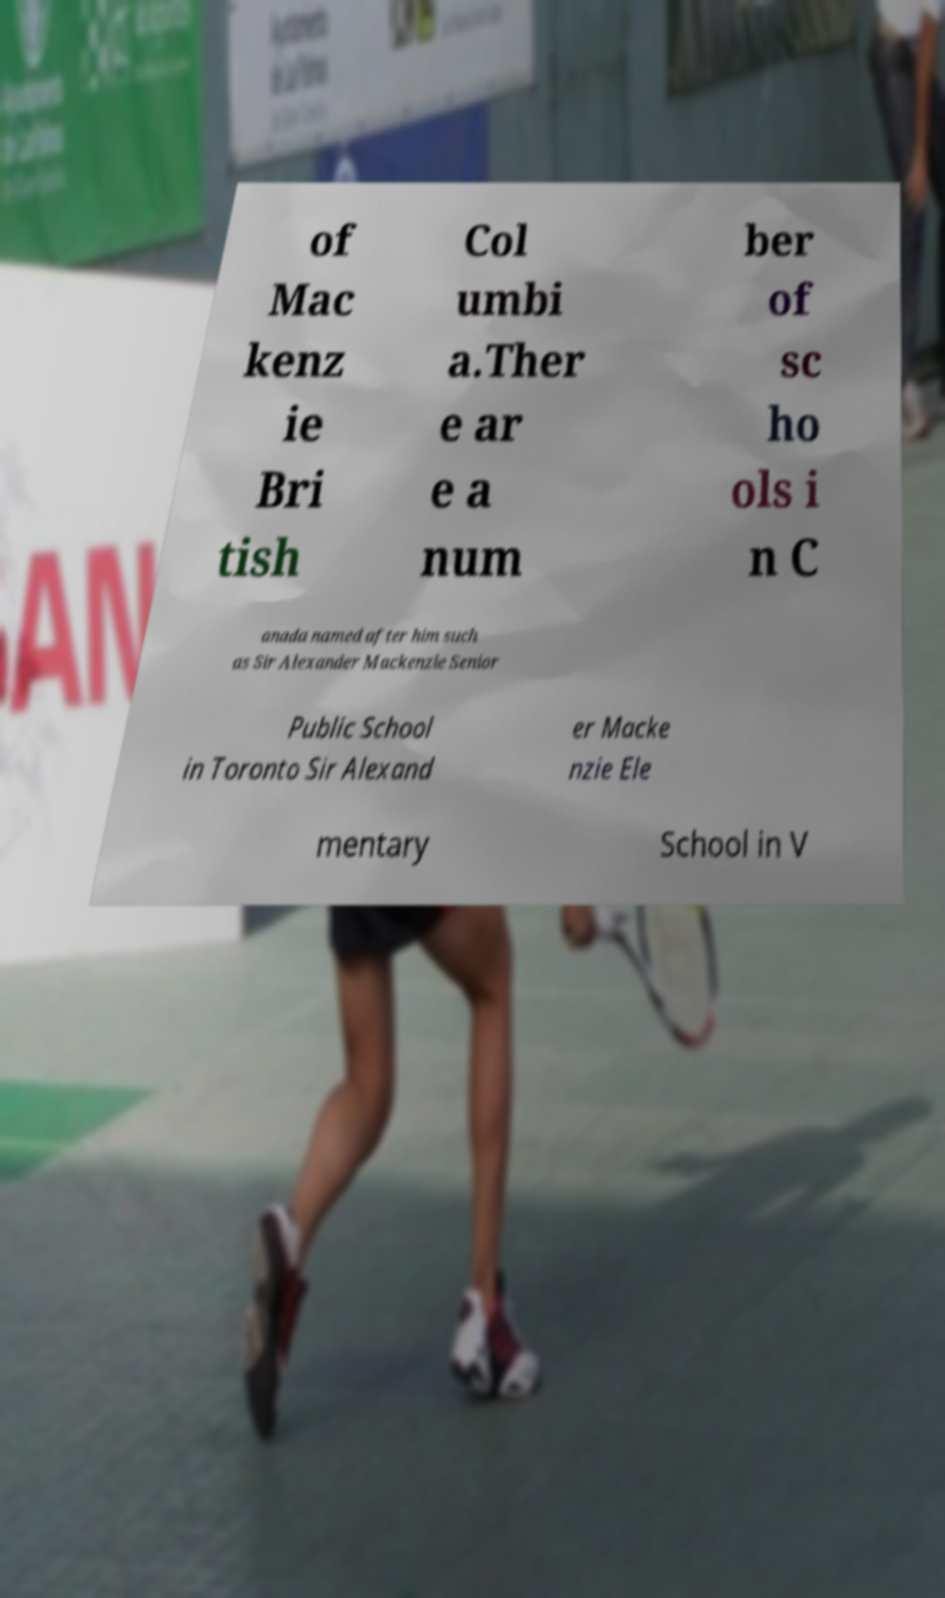What messages or text are displayed in this image? I need them in a readable, typed format. of Mac kenz ie Bri tish Col umbi a.Ther e ar e a num ber of sc ho ols i n C anada named after him such as Sir Alexander Mackenzie Senior Public School in Toronto Sir Alexand er Macke nzie Ele mentary School in V 